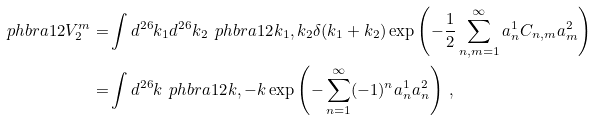<formula> <loc_0><loc_0><loc_500><loc_500>\ p h b r a { 1 2 } { V _ { 2 } ^ { m } } = & \int d ^ { 2 6 } k _ { 1 } d ^ { 2 6 } k _ { 2 } \, \ p h b r a { 1 2 } { k _ { 1 } , k _ { 2 } } \delta ( k _ { 1 } + k _ { 2 } ) \exp \left ( - \frac { 1 } { 2 } \sum _ { n , m = 1 } ^ { \infty } a _ { n } ^ { 1 } C _ { n , m } a _ { m } ^ { 2 } \right ) \\ = & \int d ^ { 2 6 } k \, \ p h b r a { 1 2 } { k , - k } \exp \left ( - \sum _ { n = 1 } ^ { \infty } ( - 1 ) ^ { n } a _ { n } ^ { 1 } a _ { n } ^ { 2 } \right ) \, ,</formula> 